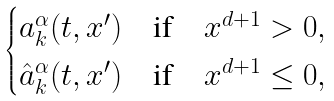<formula> <loc_0><loc_0><loc_500><loc_500>\begin{cases} a ^ { \alpha } _ { k } ( t , x ^ { \prime } ) \quad \text {if} & x ^ { d + 1 } > 0 , \\ \hat { a } ^ { \alpha } _ { k } ( t , x ^ { \prime } ) \quad \text {if} & x ^ { d + 1 } \leq 0 , \end{cases}</formula> 